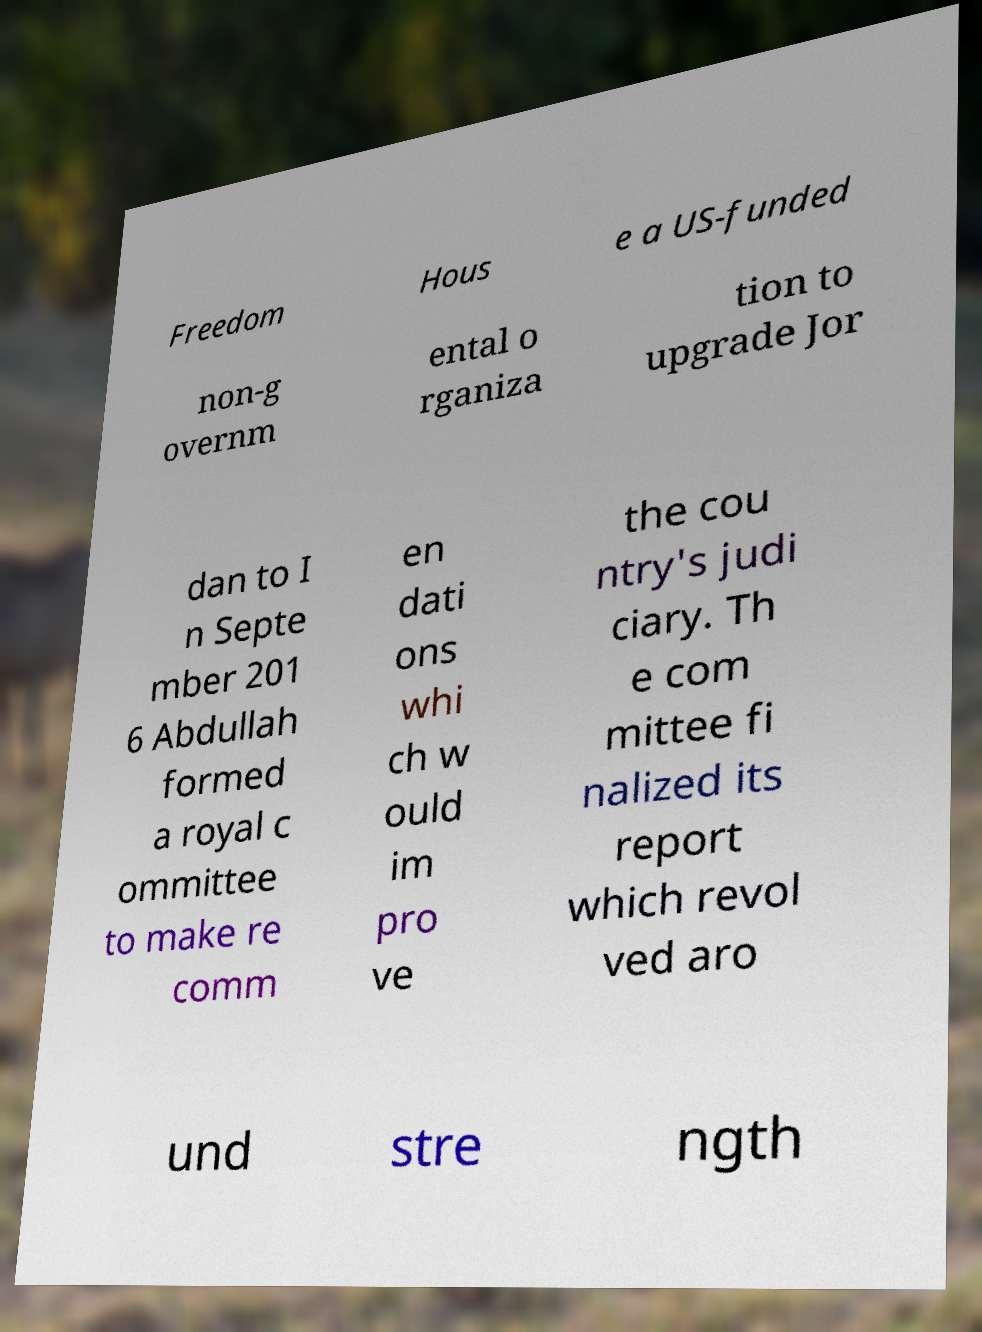Can you read and provide the text displayed in the image?This photo seems to have some interesting text. Can you extract and type it out for me? Freedom Hous e a US-funded non-g overnm ental o rganiza tion to upgrade Jor dan to I n Septe mber 201 6 Abdullah formed a royal c ommittee to make re comm en dati ons whi ch w ould im pro ve the cou ntry's judi ciary. Th e com mittee fi nalized its report which revol ved aro und stre ngth 